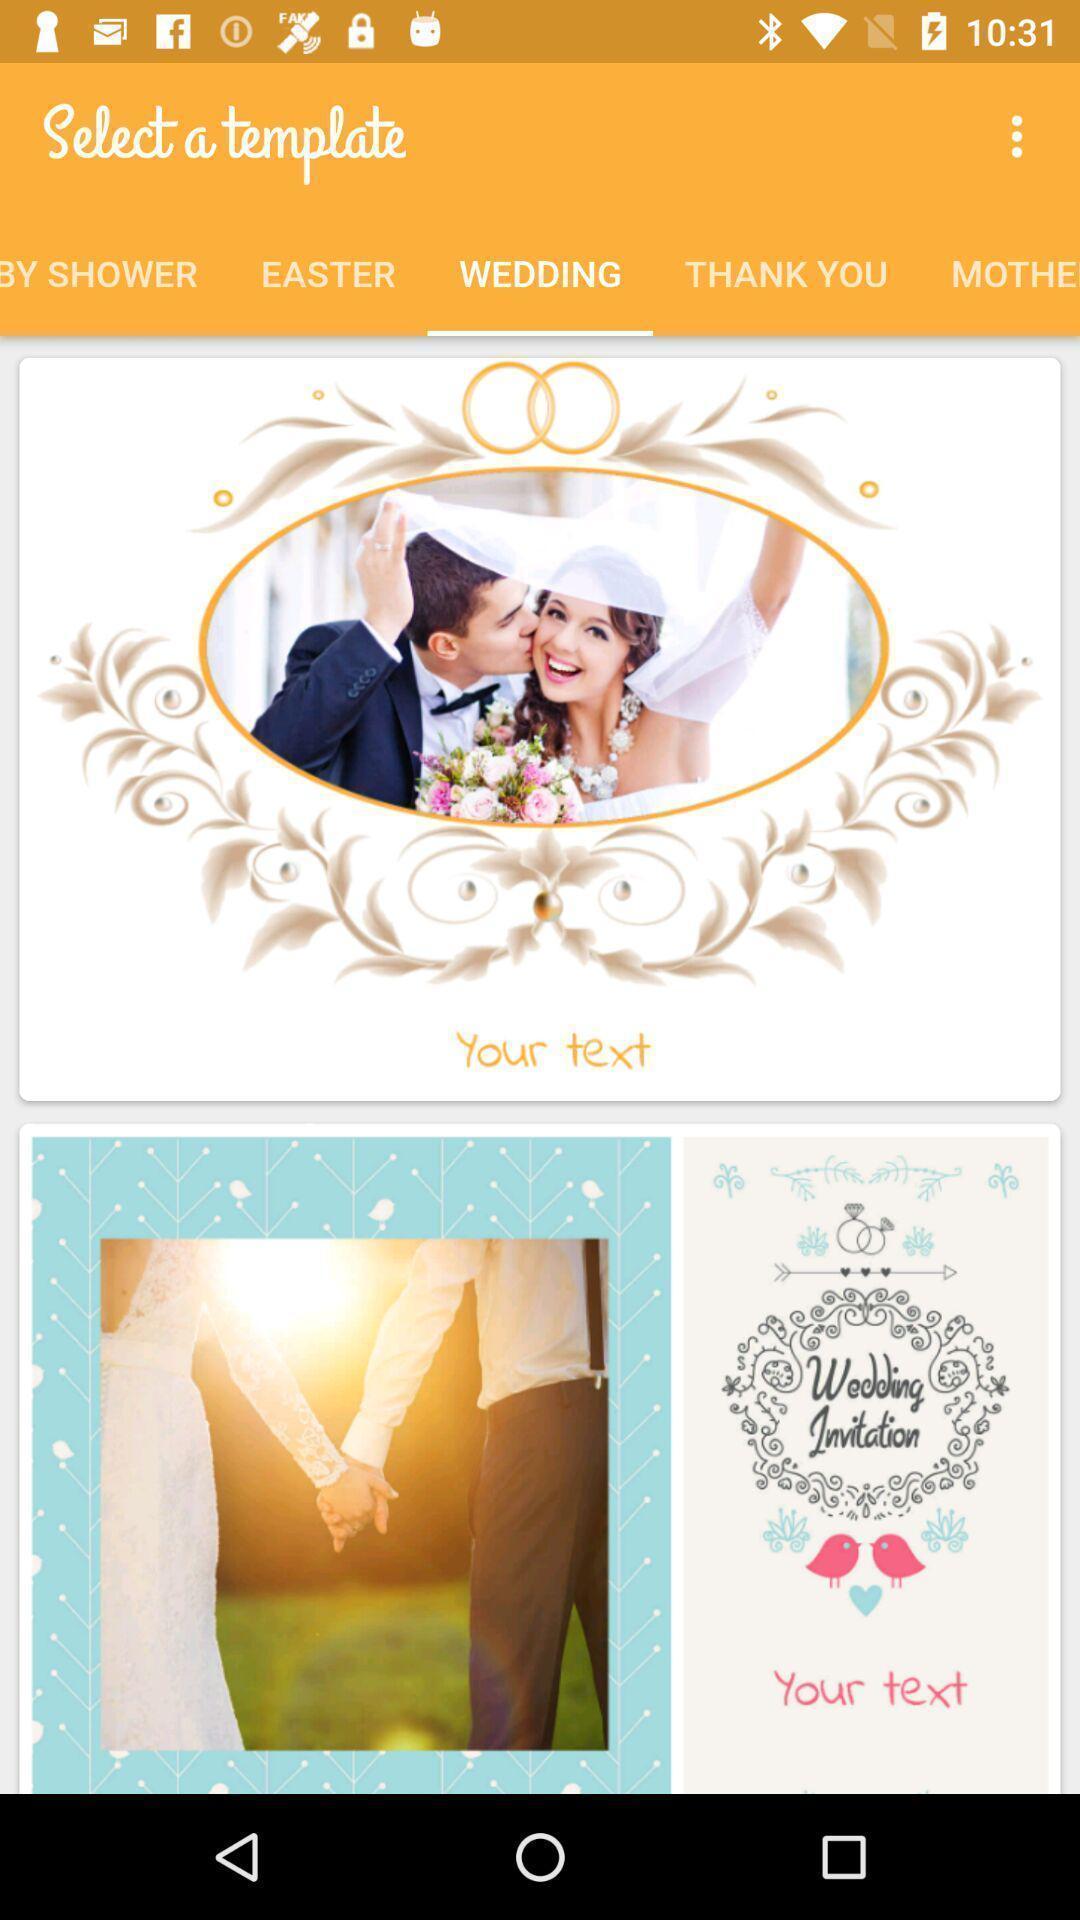Describe the content in this image. Screen page of a template selection app. 